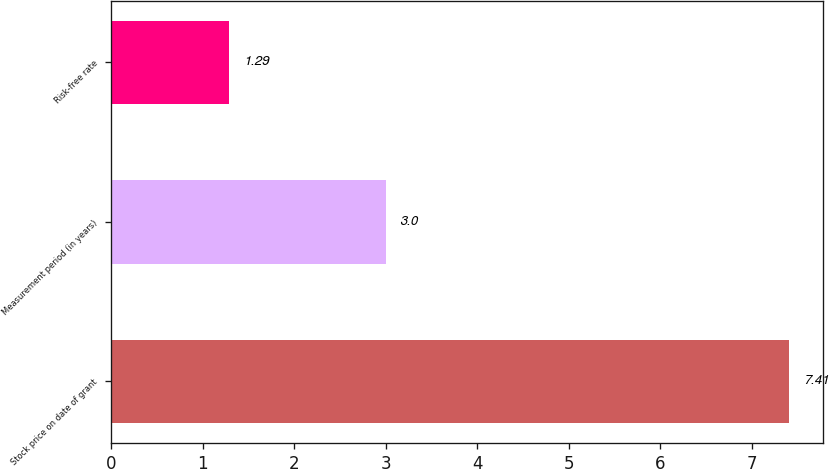Convert chart to OTSL. <chart><loc_0><loc_0><loc_500><loc_500><bar_chart><fcel>Stock price on date of grant<fcel>Measurement period (in years)<fcel>Risk-free rate<nl><fcel>7.41<fcel>3<fcel>1.29<nl></chart> 